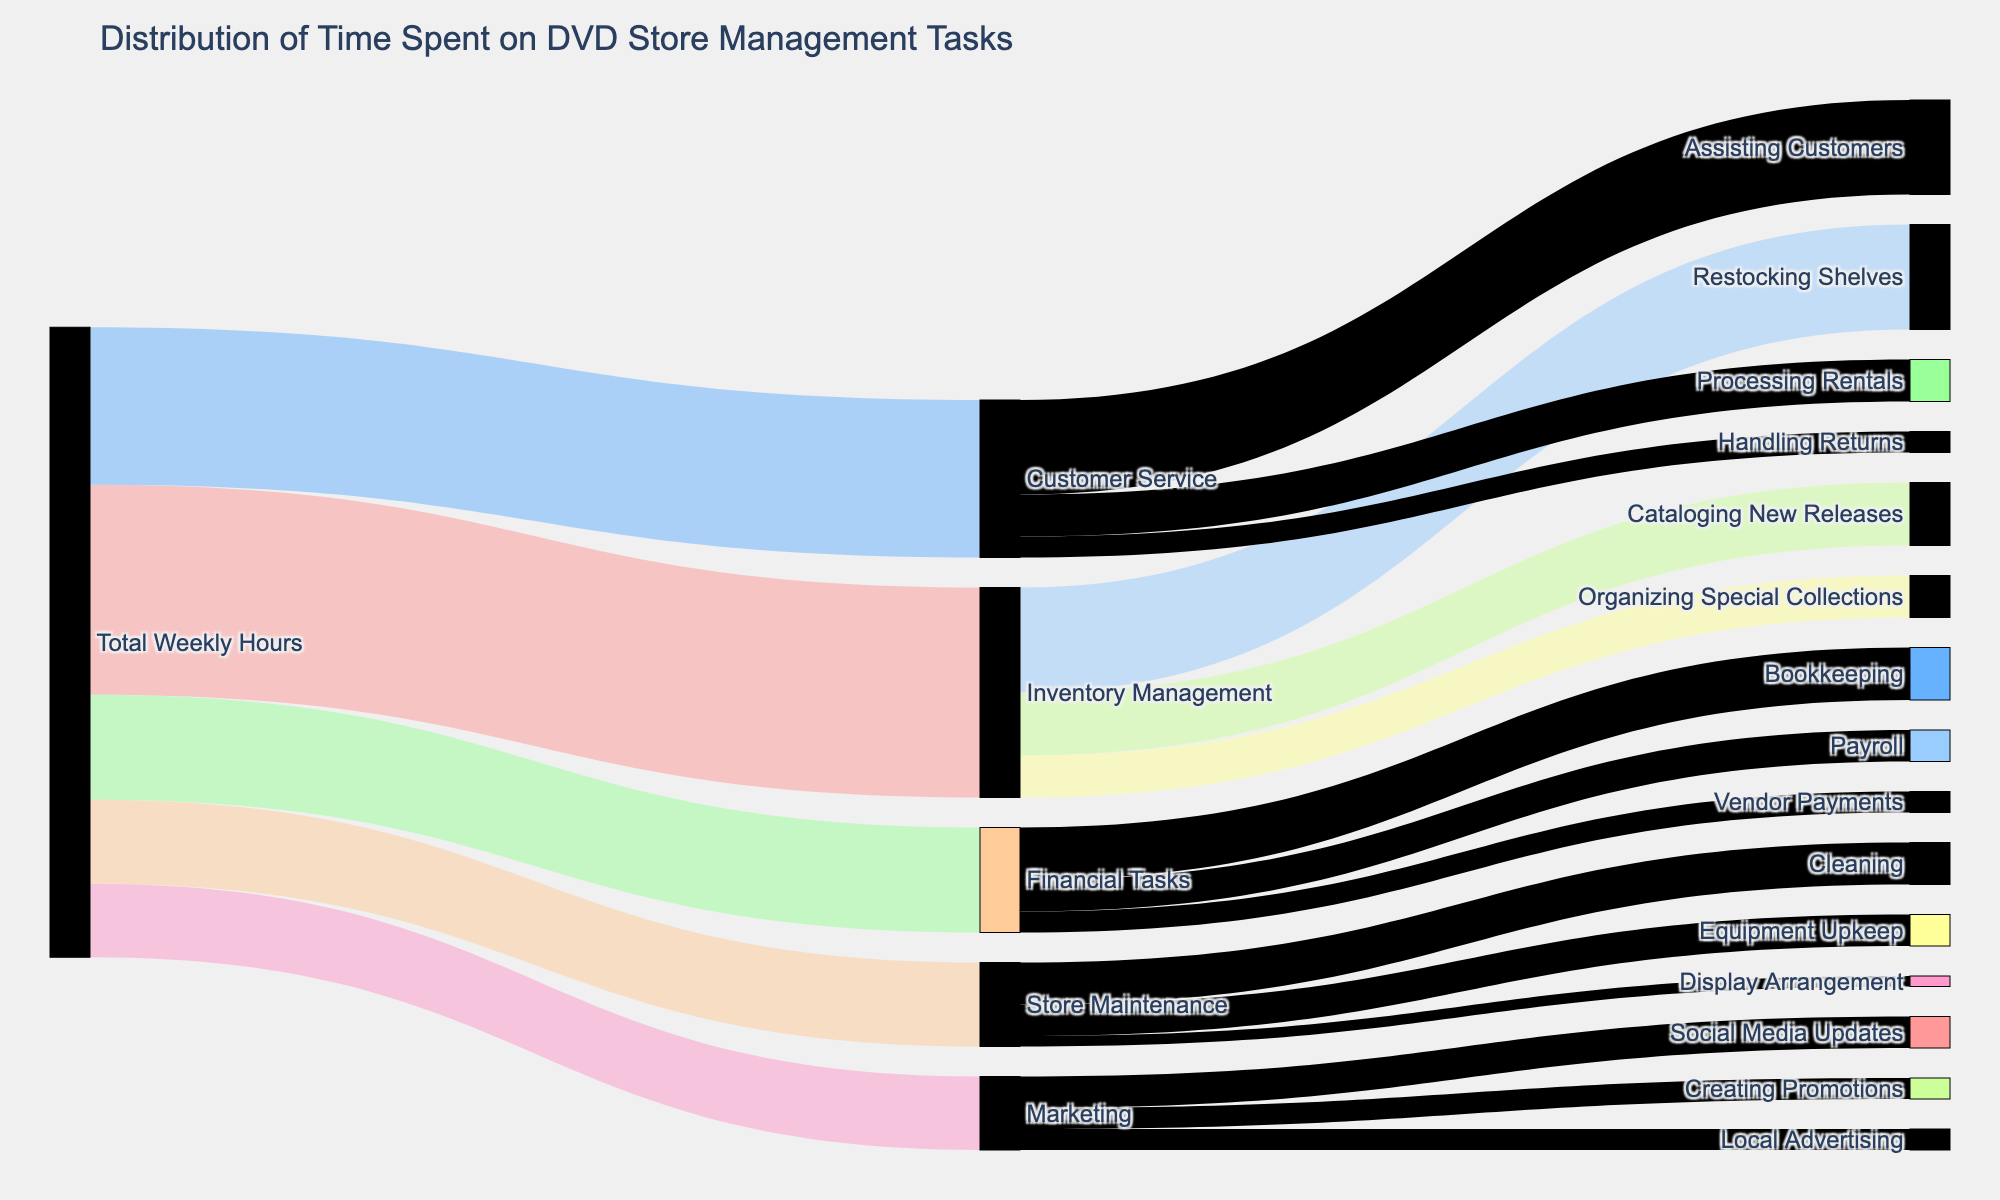What is the title of the figure? The title is displayed at the top of the Sankey diagram and reads "Distribution of Time Spent on DVD Store Management Tasks".
Answer: Distribution of Time Spent on DVD Store Management Tasks How many hours are spent on Inventory Management throughout the week? Inventory Management is connected directly to the "Total Weekly Hours" with a value of 20 hours, which is displayed on the link.
Answer: 20 hours Which task takes the least amount of time in Store Maintenance? Store Maintenance links to three tasks. The values for these tasks are 4 hours for Cleaning, 3 hours for Equipment Upkeep, and 1 hour for Display Arrangement. The smallest value is 1 hour for Display Arrangement.
Answer: Display Arrangement How many hours are spent on Marketing and what are the sub-tasks? The connection between Total Weekly Hours and Marketing shows 7 hours. The sub-tasks connected to Marketing are Social Media Updates (3 hours), Creating Promotions (2 hours), and Local Advertising (2 hours). Adding these values together also confirms 7 hours.
Answer: 7 hours, Social Media Updates, Creating Promotions, Local Advertising Which sub-task of Financial Tasks takes the most time? Financial Tasks links to Bookkeeping (5 hours), Payroll (3 hours), and Vendor Payments (2 hours). The greatest value is 5 hours for Bookkeeping.
Answer: Bookkeeping Compare the total hours spent on Customer Service and Financial Tasks. Which one has more hours? Customer Service has a total of 15 hours, and Financial Tasks have a total of 10 hours. By comparing these values, Customer Service has more hours.
Answer: Customer Service How much time is spent on Assisting Customers compared to Processing Rentals? Assisting Customers takes 9 hours, and Processing Rentals takes 4 hours. Assisting Customers takes more time.
Answer: Assisting Customers What percentage of Store Maintenance is dedicated to Cleaning? Store Maintenance totals 8 hours. Cleaning takes 4 hours. The percentage is calculated as (4 / 8) * 100 = 50%.
Answer: 50% Which main task has the second-highest total weekly hours? Total Weekly Hours distributes into Inventory Management, Customer Service, Financial Tasks, Store Maintenance, and Marketing. Their values are 20, 15, 10, 8, and 7 hours respectively. The second-highest is Customer Service with 15 hours.
Answer: Customer Service How many hours in total are spent on tasks directly linked to Customer Service? Customer Service is linked to Assisting Customers (9 hours), Processing Rentals (4 hours), and Handling Returns (2 hours). Summing these values gives 9 + 4 + 2 = 15 hours.
Answer: 15 hours 